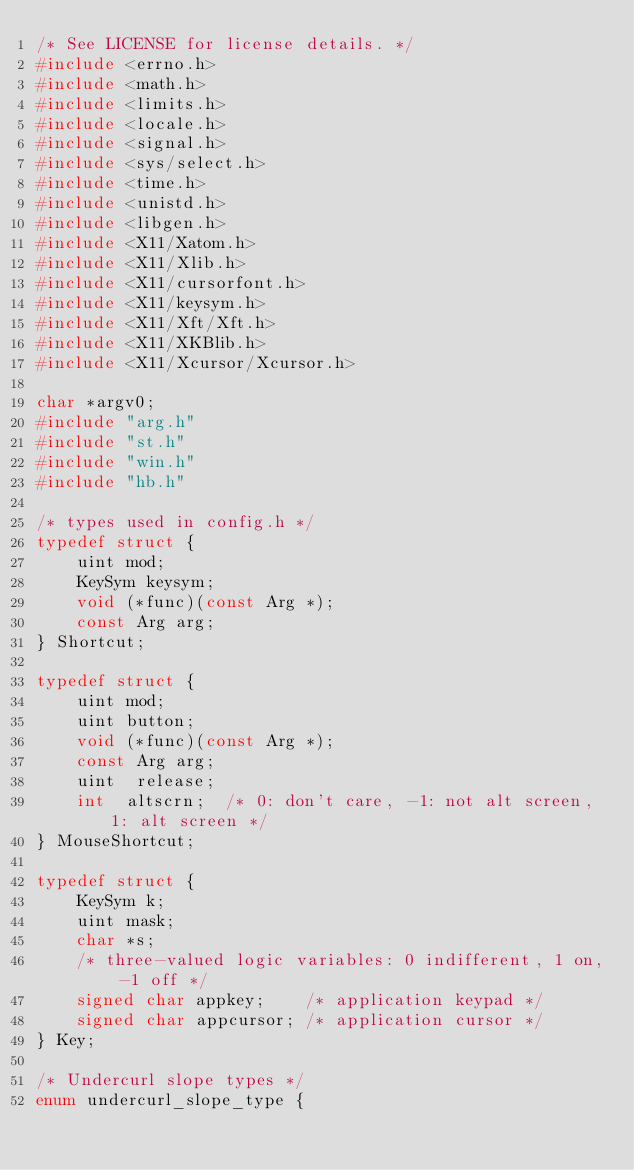<code> <loc_0><loc_0><loc_500><loc_500><_C_>/* See LICENSE for license details. */
#include <errno.h>
#include <math.h>
#include <limits.h>
#include <locale.h>
#include <signal.h>
#include <sys/select.h>
#include <time.h>
#include <unistd.h>
#include <libgen.h>
#include <X11/Xatom.h>
#include <X11/Xlib.h>
#include <X11/cursorfont.h>
#include <X11/keysym.h>
#include <X11/Xft/Xft.h>
#include <X11/XKBlib.h>
#include <X11/Xcursor/Xcursor.h>

char *argv0;
#include "arg.h"
#include "st.h"
#include "win.h"
#include "hb.h"

/* types used in config.h */
typedef struct {
	uint mod;
	KeySym keysym;
	void (*func)(const Arg *);
	const Arg arg;
} Shortcut;

typedef struct {
	uint mod;
	uint button;
	void (*func)(const Arg *);
	const Arg arg;
	uint  release;
	int  altscrn;  /* 0: don't care, -1: not alt screen, 1: alt screen */
} MouseShortcut;

typedef struct {
	KeySym k;
	uint mask;
	char *s;
	/* three-valued logic variables: 0 indifferent, 1 on, -1 off */
	signed char appkey;    /* application keypad */
	signed char appcursor; /* application cursor */
} Key;

/* Undercurl slope types */
enum undercurl_slope_type {</code> 